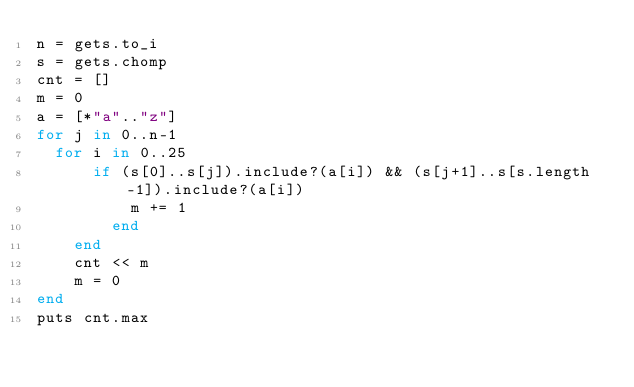Convert code to text. <code><loc_0><loc_0><loc_500><loc_500><_Ruby_>n = gets.to_i
s = gets.chomp
cnt = []
m = 0
a = [*"a".."z"]
for j in 0..n-1
	for i in 0..25
  		if (s[0]..s[j]).include?(a[i]) && (s[j+1]..s[s.length-1]).include?(a[i])
  		    m += 1
        end
    end
    cnt << m
    m = 0
end
puts cnt.max</code> 